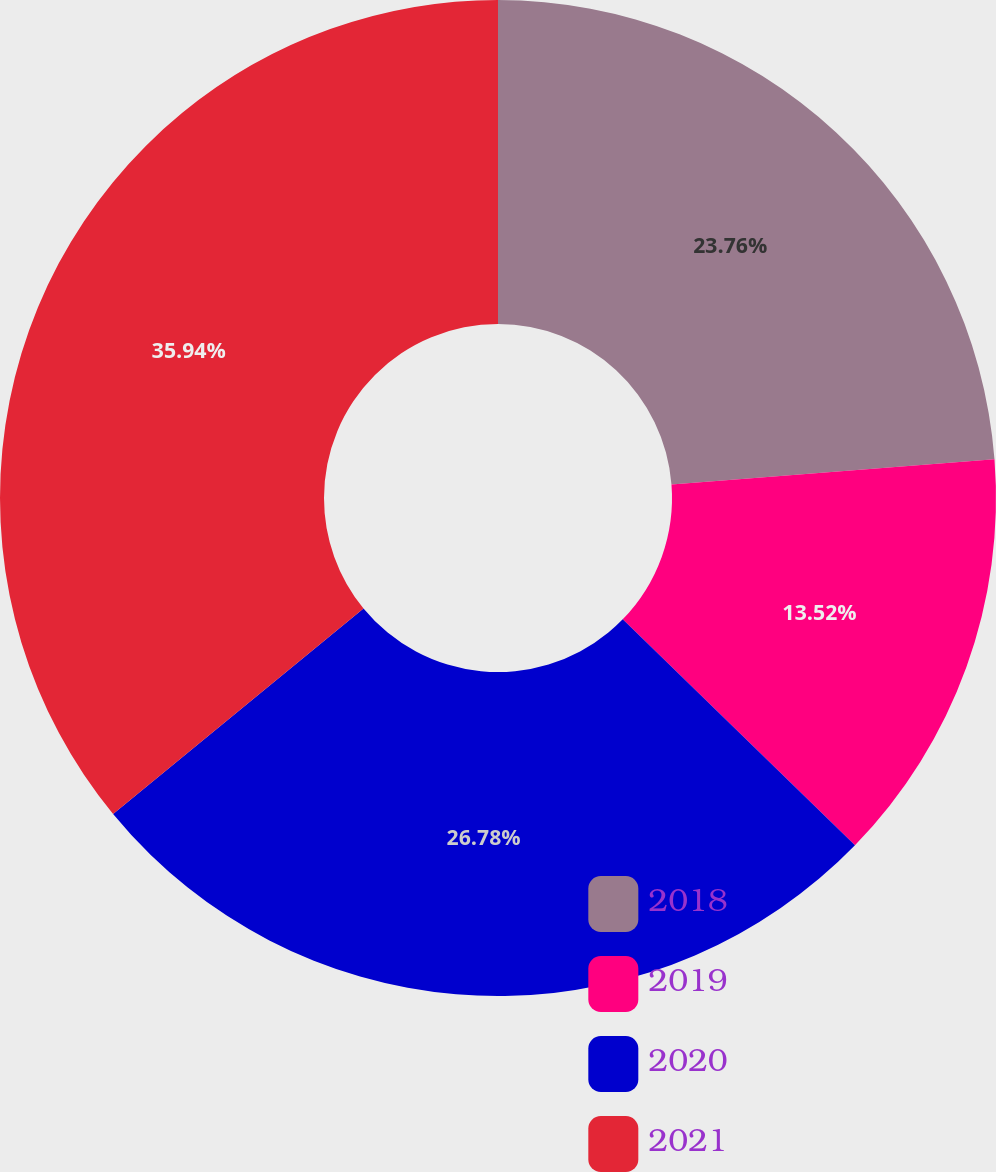<chart> <loc_0><loc_0><loc_500><loc_500><pie_chart><fcel>2018<fcel>2019<fcel>2020<fcel>2021<nl><fcel>23.76%<fcel>13.52%<fcel>26.78%<fcel>35.94%<nl></chart> 